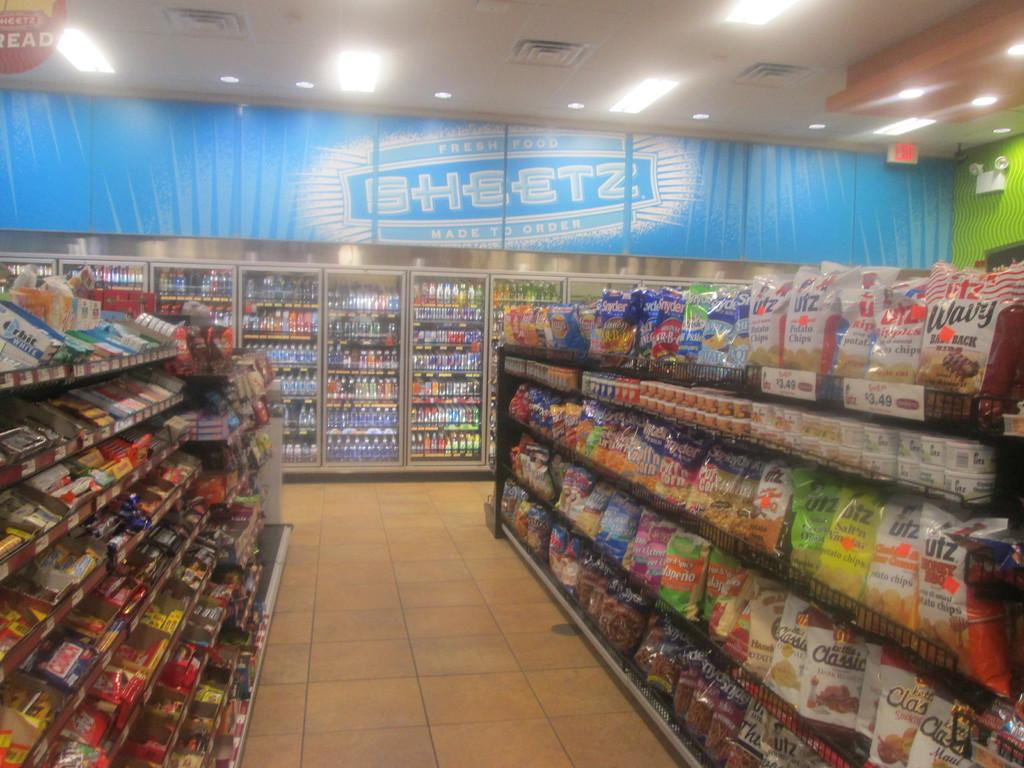Provide a one-sentence caption for the provided image. A sign that says SHEETZ is above the drink cases in this store. 